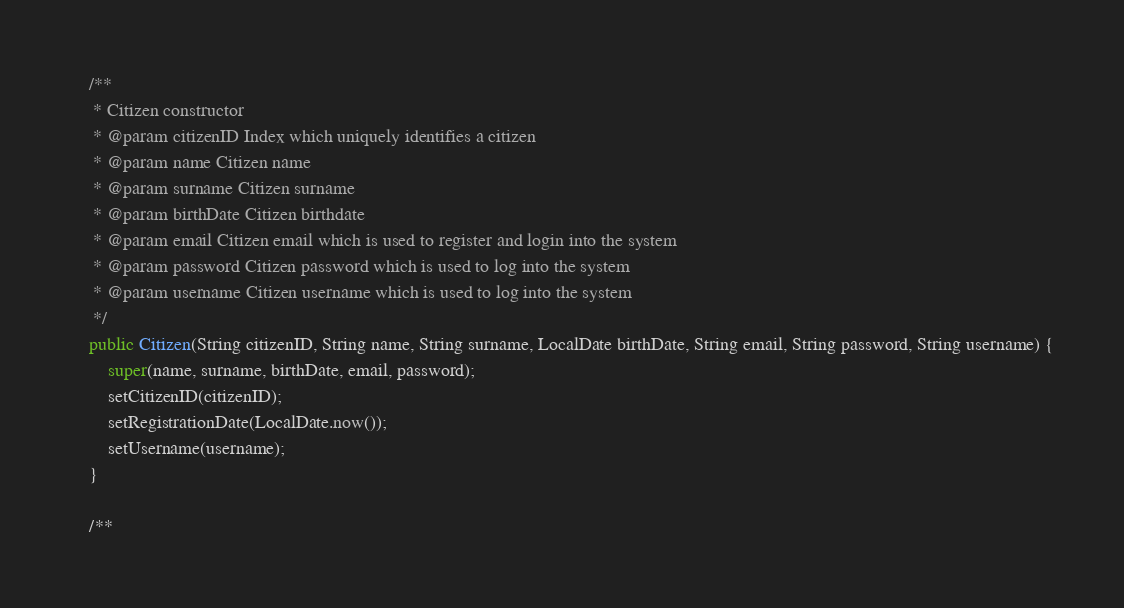Convert code to text. <code><loc_0><loc_0><loc_500><loc_500><_Java_>

    /**
     * Citizen constructor
     * @param citizenID Index which uniquely identifies a citizen
     * @param name Citizen name
     * @param surname Citizen surname
     * @param birthDate Citizen birthdate
     * @param email Citizen email which is used to register and login into the system
     * @param password Citizen password which is used to log into the system
     * @param username Citizen username which is used to log into the system
     */
    public Citizen(String citizenID, String name, String surname, LocalDate birthDate, String email, String password, String username) {
        super(name, surname, birthDate, email, password);
        setCitizenID(citizenID);
        setRegistrationDate(LocalDate.now());
        setUsername(username);
    }

    /**</code> 